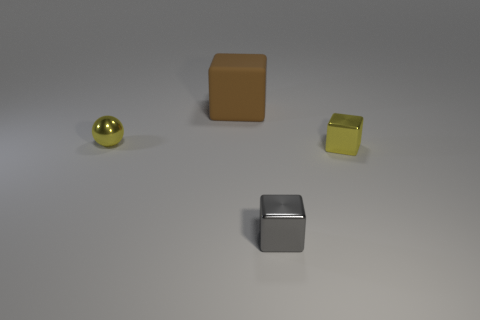There is a small yellow object that is the same shape as the large brown object; what is it made of?
Keep it short and to the point. Metal. What is the shape of the yellow object that is made of the same material as the yellow cube?
Provide a short and direct response. Sphere. What number of metallic objects are the same color as the tiny metallic ball?
Keep it short and to the point. 1. What number of other objects are the same color as the tiny metallic ball?
Make the answer very short. 1. Does the shiny block right of the gray metallic cube have the same size as the brown cube?
Your response must be concise. No. Is the large block the same color as the sphere?
Ensure brevity in your answer.  No. There is a small metal cube in front of the yellow block; what number of large cubes are to the right of it?
Offer a terse response. 0. How big is the brown matte object?
Your answer should be very brief. Large. Is the material of the small ball the same as the yellow block?
Your response must be concise. Yes. How many blocks are either large brown things or yellow shiny objects?
Offer a very short reply. 2. 